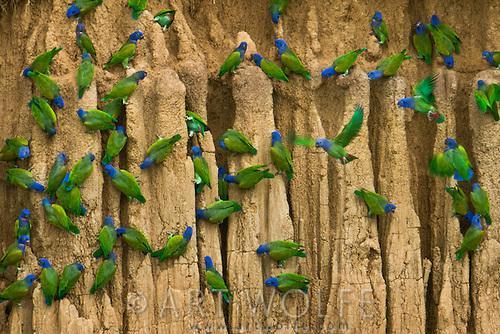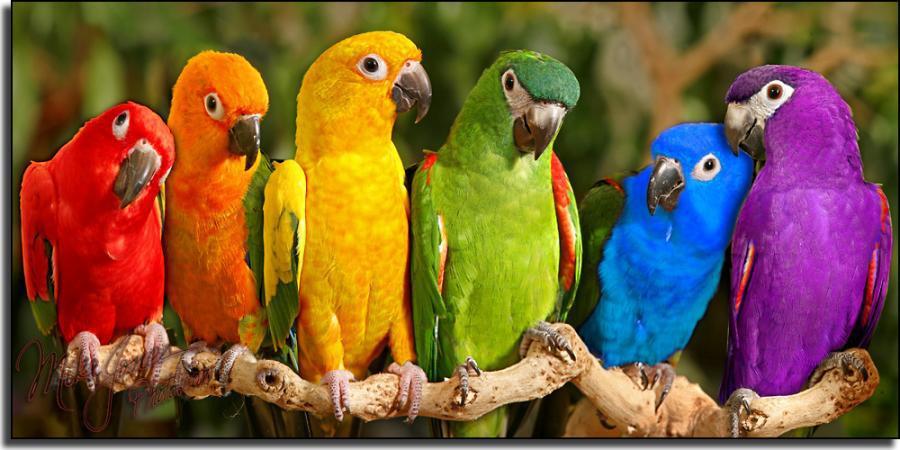The first image is the image on the left, the second image is the image on the right. For the images shown, is this caption "One image contains exactly six birds." true? Answer yes or no. Yes. The first image is the image on the left, the second image is the image on the right. Analyze the images presented: Is the assertion "The right image shows a row of at least five blue and yellow-orange parrots." valid? Answer yes or no. No. 